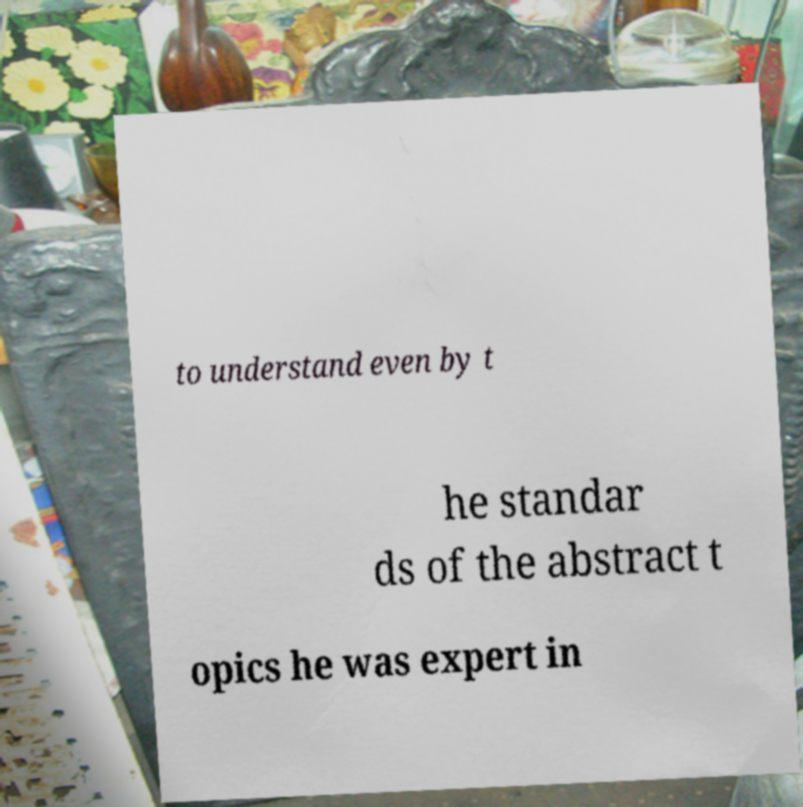Please identify and transcribe the text found in this image. to understand even by t he standar ds of the abstract t opics he was expert in 